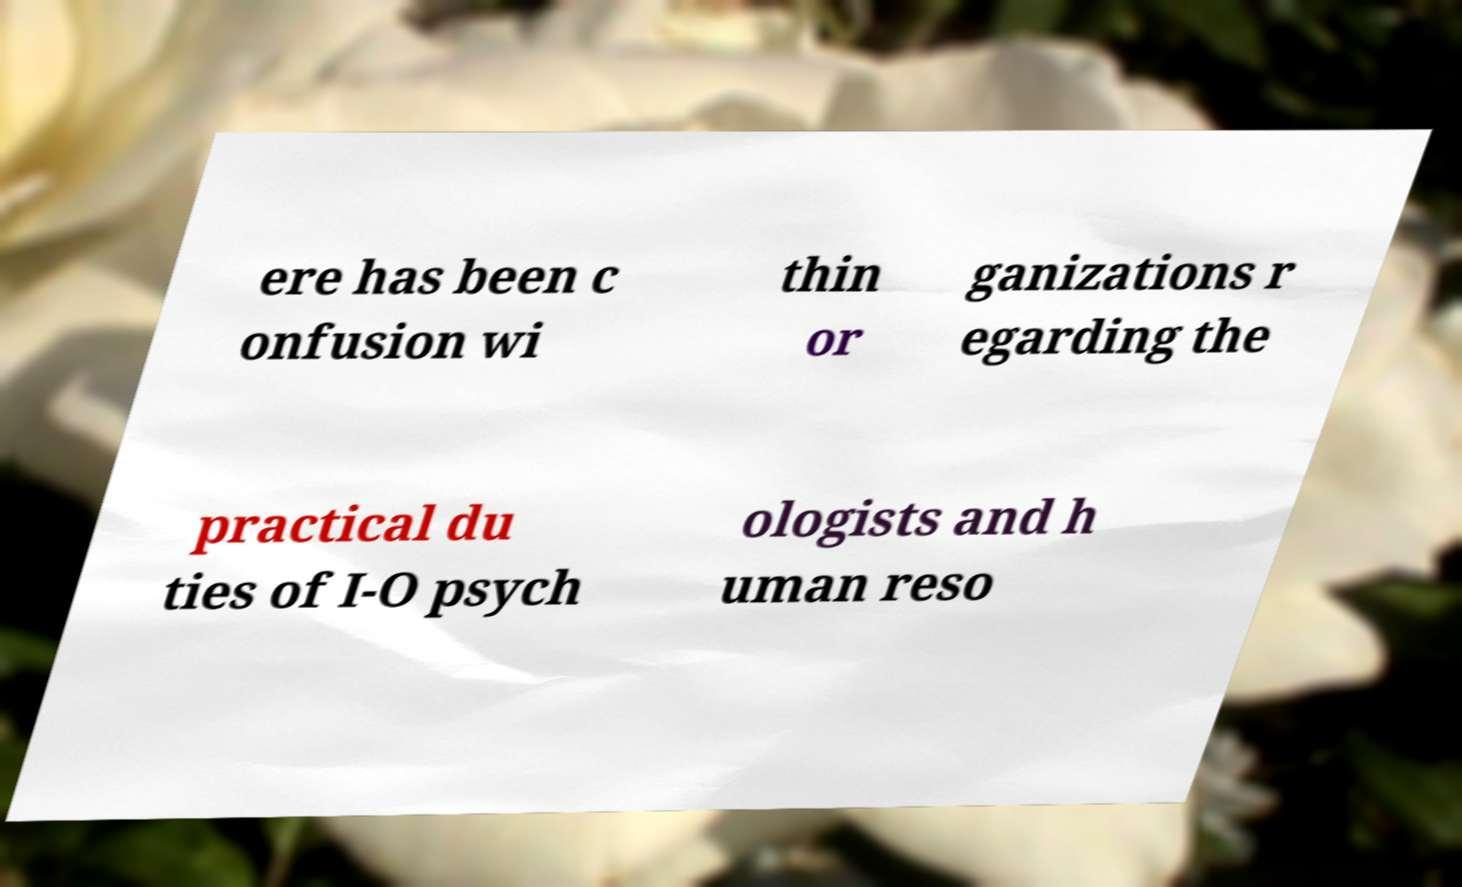Please read and relay the text visible in this image. What does it say? ere has been c onfusion wi thin or ganizations r egarding the practical du ties of I-O psych ologists and h uman reso 